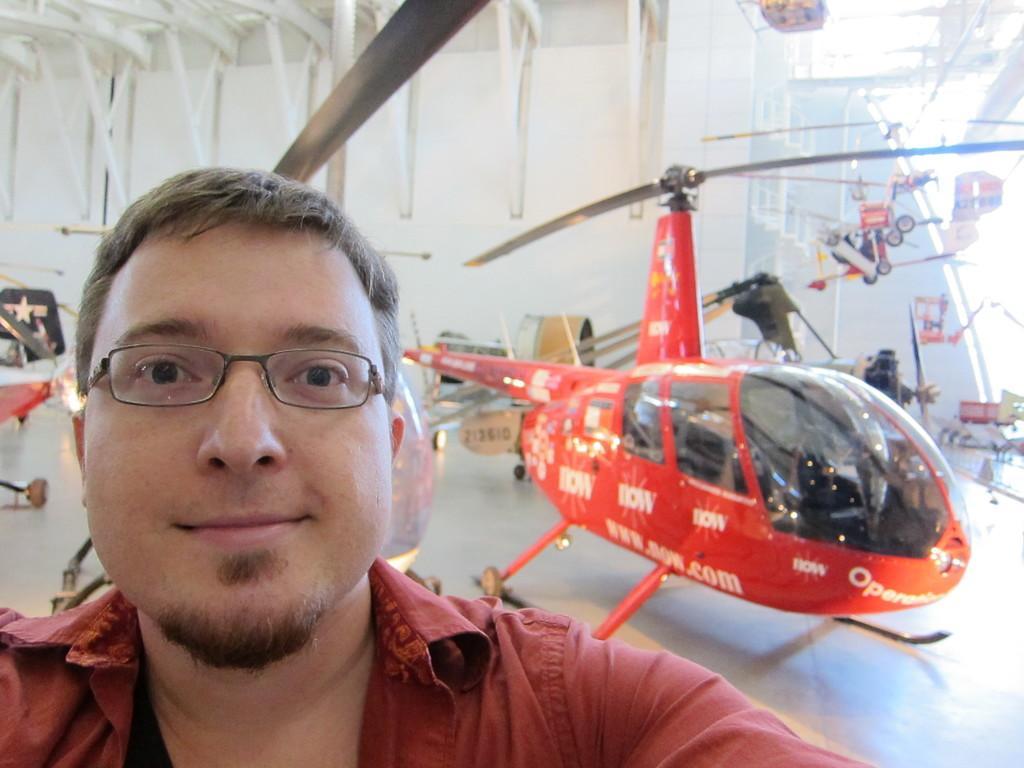Please provide a concise description of this image. In this picture I can see there is a man standing and he is wearing a shirt and in the backdrop I can see there is a helicopter and it has cabins and in the backdrop I can see there is a wall and iron frame attached to the ceiling. 